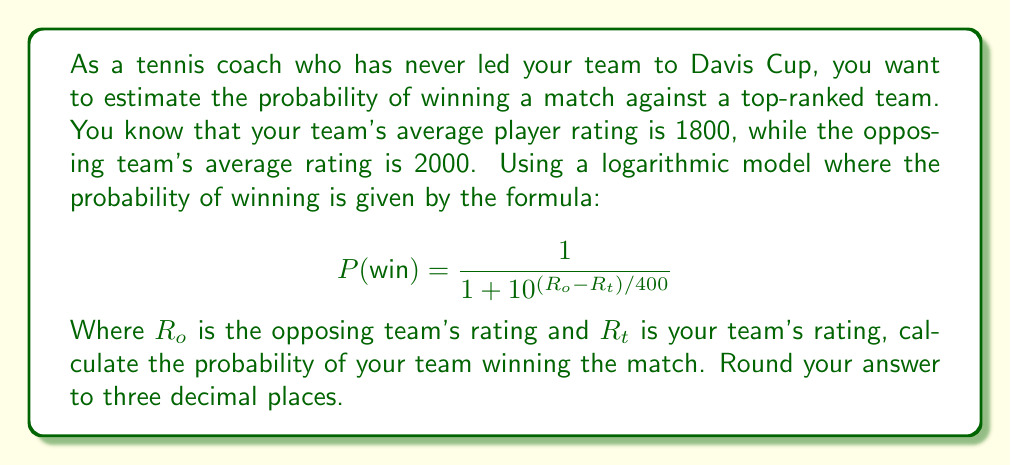Teach me how to tackle this problem. To solve this problem, we'll follow these steps:

1. Identify the given information:
   $R_t$ (your team's rating) = 1800
   $R_o$ (opposing team's rating) = 2000

2. Substitute these values into the formula:

   $$ P(\text{win}) = \frac{1}{1 + 10^{(2000 - 1800)/400}} $$

3. Simplify the exponent:
   
   $$ P(\text{win}) = \frac{1}{1 + 10^{200/400}} = \frac{1}{1 + 10^{0.5}} $$

4. Calculate $10^{0.5}$:
   
   $10^{0.5} \approx 3.16227766$

5. Substitute this value and calculate:

   $$ P(\text{win}) = \frac{1}{1 + 3.16227766} = \frac{1}{4.16227766} $$

6. Divide and round to three decimal places:

   $$ P(\text{win}) \approx 0.240 $$
Answer: The probability of your team winning the match is approximately 0.240 or 24.0%. 